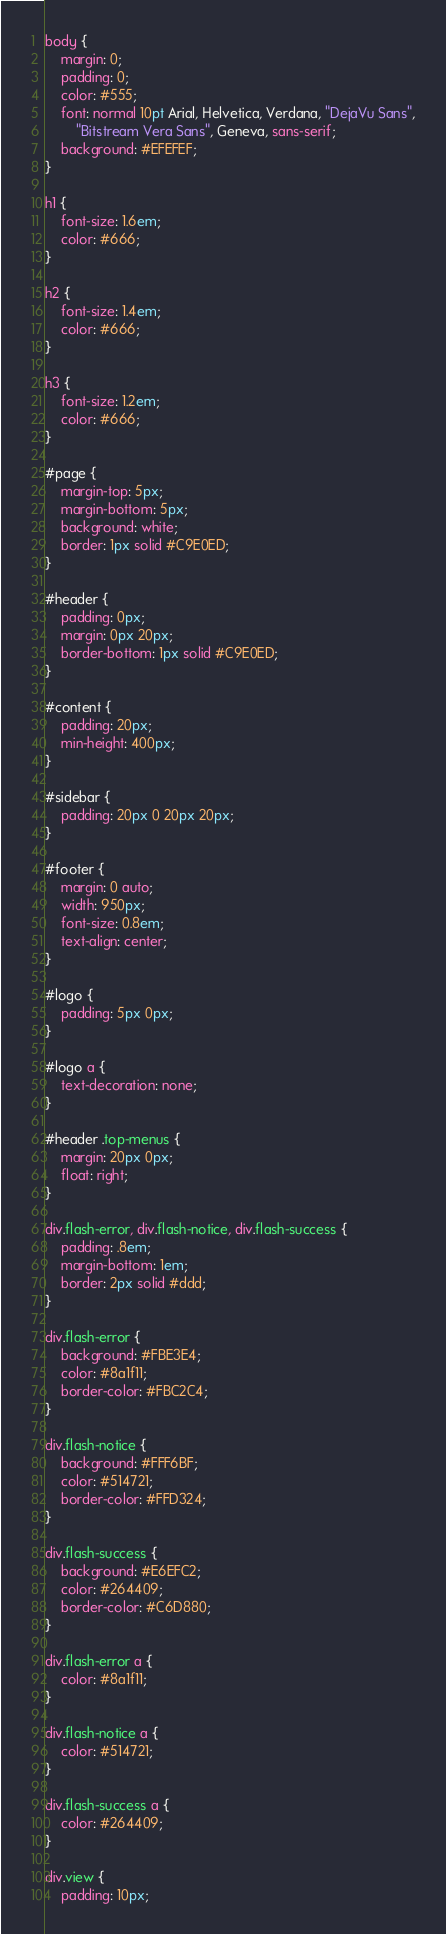Convert code to text. <code><loc_0><loc_0><loc_500><loc_500><_CSS_>body {
	margin: 0;
	padding: 0;
	color: #555;
	font: normal 10pt Arial, Helvetica, Verdana, "DejaVu Sans",
		"Bitstream Vera Sans", Geneva, sans-serif;
	background: #EFEFEF;
}

h1 {
	font-size: 1.6em;
	color: #666;
}

h2 {
	font-size: 1.4em;
	color: #666;
}

h3 {
	font-size: 1.2em;
	color: #666;
}

#page {
	margin-top: 5px;
	margin-bottom: 5px;
	background: white;
	border: 1px solid #C9E0ED;
}

#header {
	padding: 0px;
	margin: 0px 20px;
	border-bottom: 1px solid #C9E0ED;
}

#content {
	padding: 20px;
	min-height: 400px;
}

#sidebar {
	padding: 20px 0 20px 20px;
}

#footer {
	margin: 0 auto;
	width: 950px;
	font-size: 0.8em;
	text-align: center;
}

#logo {
	padding: 5px 0px;
}

#logo a {
	text-decoration: none;
}

#header .top-menus {
	margin: 20px 0px;
	float: right;
}

div.flash-error, div.flash-notice, div.flash-success {
	padding: .8em;
	margin-bottom: 1em;
	border: 2px solid #ddd;
}

div.flash-error {
	background: #FBE3E4;
	color: #8a1f11;
	border-color: #FBC2C4;
}

div.flash-notice {
	background: #FFF6BF;
	color: #514721;
	border-color: #FFD324;
}

div.flash-success {
	background: #E6EFC2;
	color: #264409;
	border-color: #C6D880;
}

div.flash-error a {
	color: #8a1f11;
}

div.flash-notice a {
	color: #514721;
}

div.flash-success a {
	color: #264409;
}

div.view {
	padding: 10px;</code> 